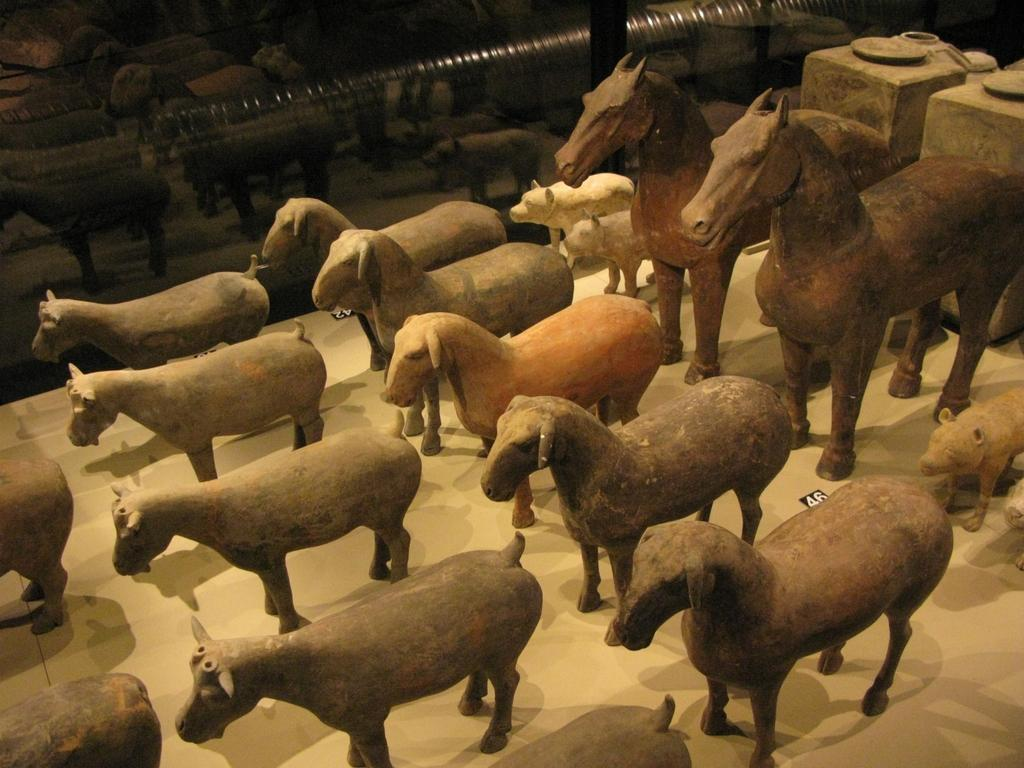What type of toys are present in the image? There are wooden toys in the image. What animals do the wooden toys resemble? The wooden toys resemble sheep, horses, and other animals. Can you describe any other objects in the background of the image? There is a glass in the background of the image. What type of spark can be seen coming from the wooden toys in the image? There is no spark present in the image; the toys are wooden and do not produce sparks. 